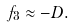<formula> <loc_0><loc_0><loc_500><loc_500>f _ { 3 } \approx - D .</formula> 